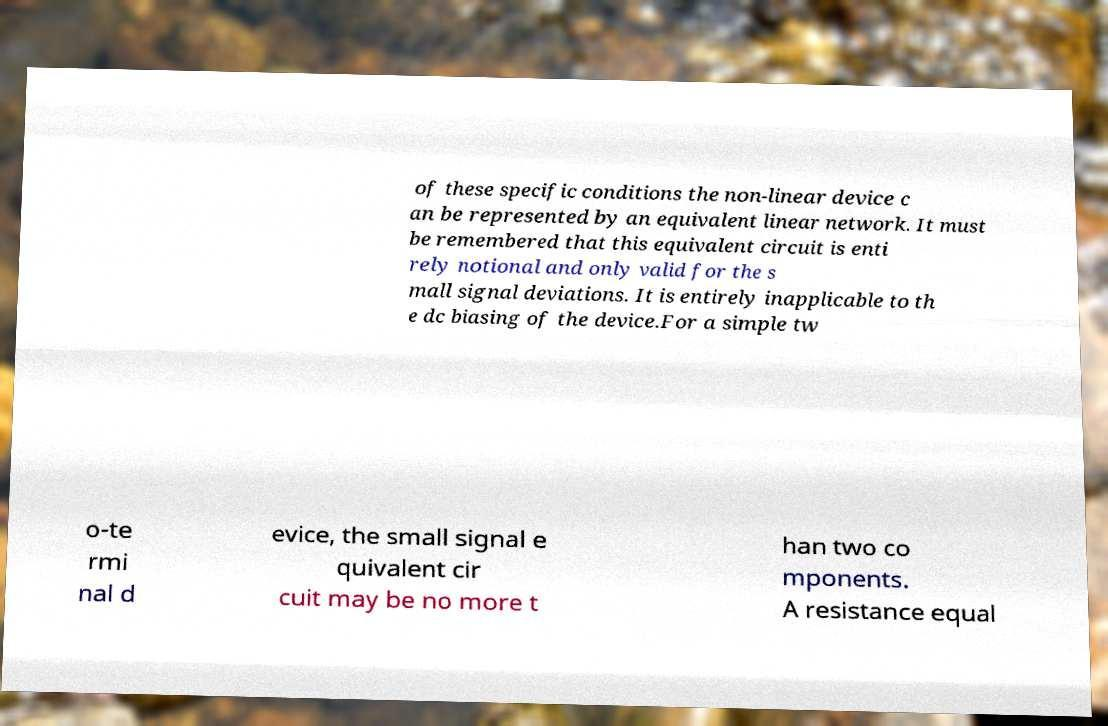Could you extract and type out the text from this image? of these specific conditions the non-linear device c an be represented by an equivalent linear network. It must be remembered that this equivalent circuit is enti rely notional and only valid for the s mall signal deviations. It is entirely inapplicable to th e dc biasing of the device.For a simple tw o-te rmi nal d evice, the small signal e quivalent cir cuit may be no more t han two co mponents. A resistance equal 